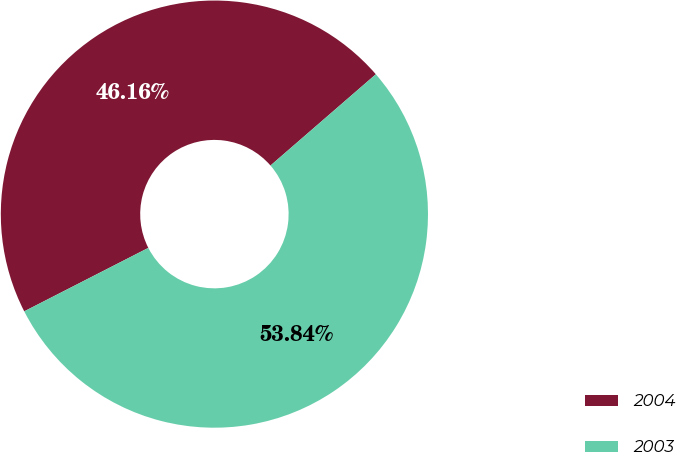Convert chart. <chart><loc_0><loc_0><loc_500><loc_500><pie_chart><fcel>2004<fcel>2003<nl><fcel>46.16%<fcel>53.84%<nl></chart> 